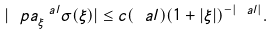Convert formula to latex. <formula><loc_0><loc_0><loc_500><loc_500>| \ p a _ { \xi } ^ { \ a l } \sigma ( \xi ) | \leq c ( \ a l ) ( 1 + | \xi | ) ^ { - | \ a l | } .</formula> 